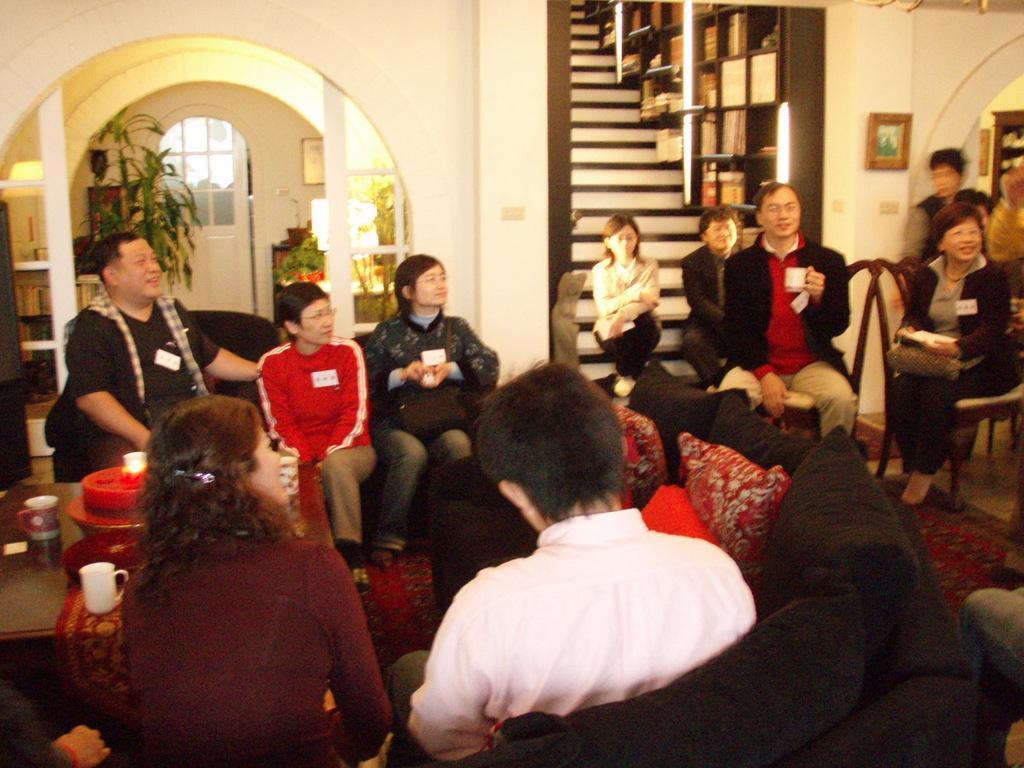Please provide a concise description of this image. In this image we can see men and women are sitting on sofa and chair. Left side of the image, one table is there. On table cups, cloth and things are there. Background of the image stairs, white color door, wall, frame and plants are there. Two persons are sitting on the stairs. 